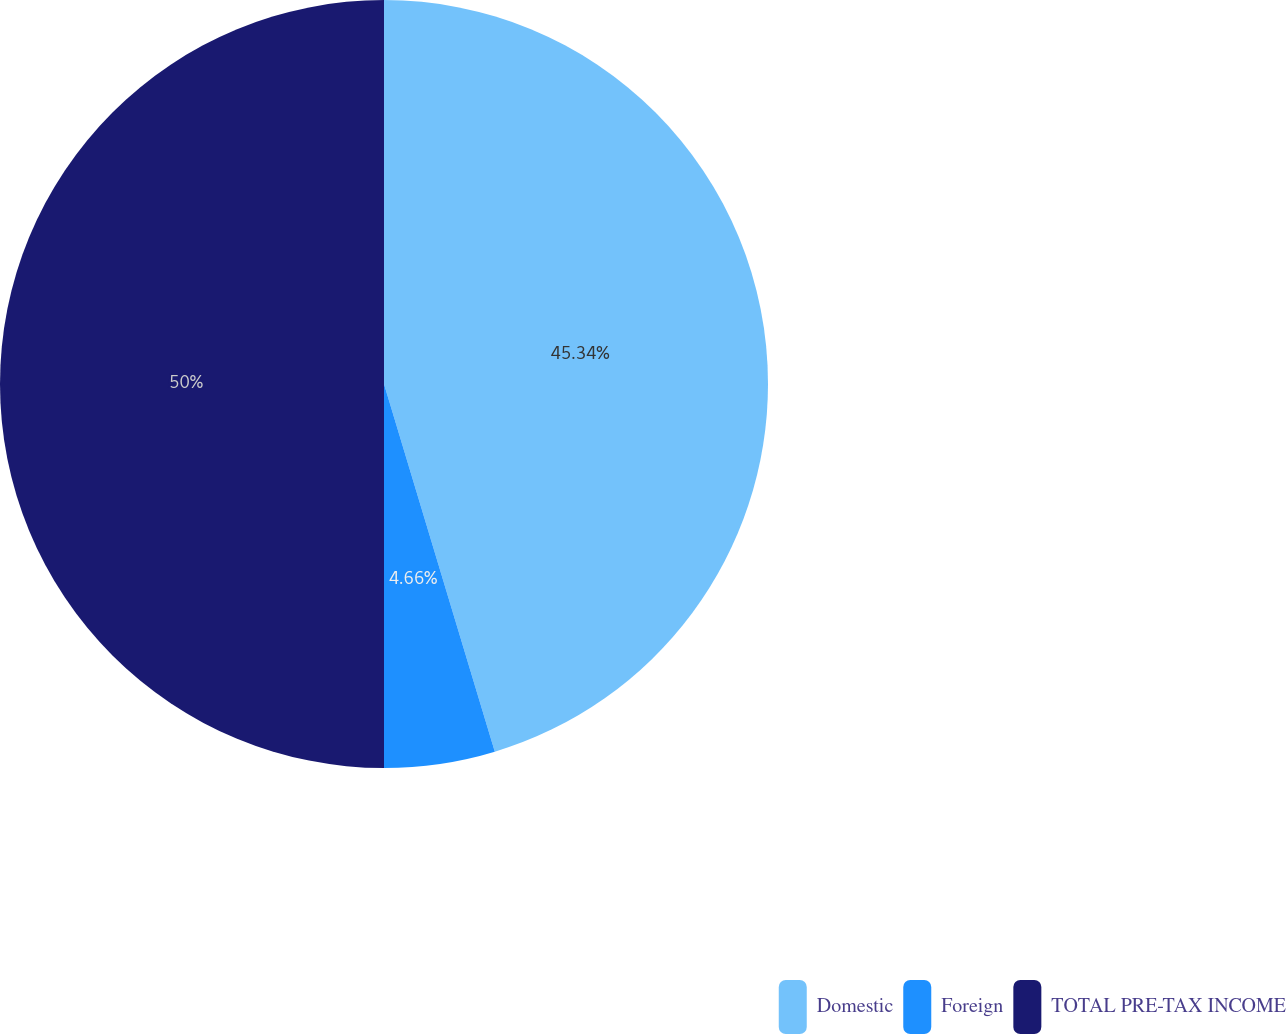Convert chart to OTSL. <chart><loc_0><loc_0><loc_500><loc_500><pie_chart><fcel>Domestic<fcel>Foreign<fcel>TOTAL PRE-TAX INCOME<nl><fcel>45.34%<fcel>4.66%<fcel>50.0%<nl></chart> 